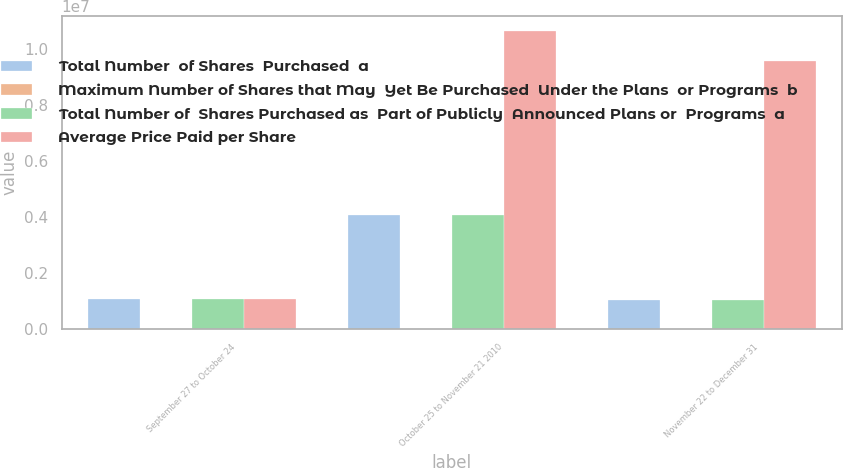Convert chart to OTSL. <chart><loc_0><loc_0><loc_500><loc_500><stacked_bar_chart><ecel><fcel>September 27 to October 24<fcel>October 25 to November 21 2010<fcel>November 22 to December 31<nl><fcel>Total Number  of Shares  Purchased  a<fcel>1.09259e+06<fcel>4.07026e+06<fcel>1.05558e+06<nl><fcel>Maximum Number of Shares that May  Yet Be Purchased  Under the Plans  or Programs  b<fcel>30.45<fcel>32.07<fcel>34.12<nl><fcel>Total Number of  Shares Purchased as  Part of Publicly  Announced Plans or  Programs  a<fcel>1.09259e+06<fcel>4.07026e+06<fcel>1.05558e+06<nl><fcel>Average Price Paid per Share<fcel>1.09259e+06<fcel>1.06429e+07<fcel>9.58732e+06<nl></chart> 